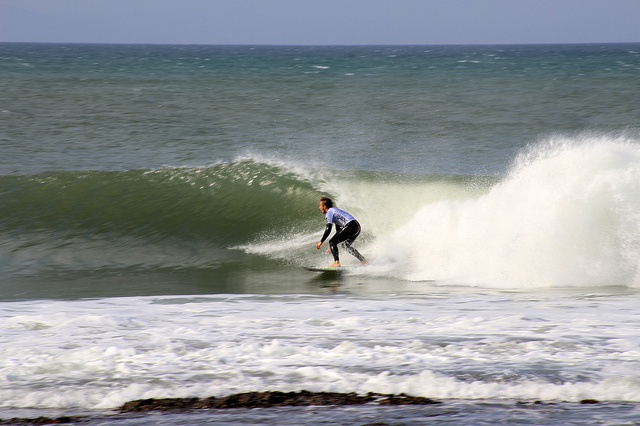Describe the objects in this image and their specific colors. I can see people in darkgray, black, and gray tones and surfboard in darkgray, lightgray, black, and gray tones in this image. 